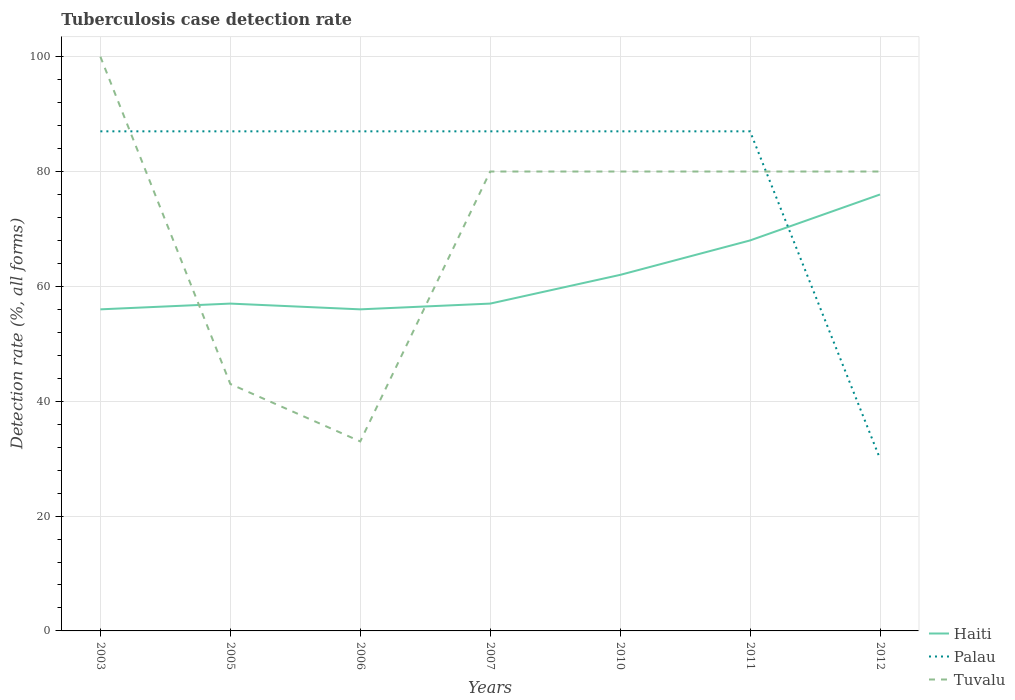How many different coloured lines are there?
Give a very brief answer. 3. Is the number of lines equal to the number of legend labels?
Make the answer very short. Yes. What is the difference between the highest and the second highest tuberculosis case detection rate in in Palau?
Ensure brevity in your answer.  57. What is the difference between two consecutive major ticks on the Y-axis?
Keep it short and to the point. 20. Are the values on the major ticks of Y-axis written in scientific E-notation?
Keep it short and to the point. No. Does the graph contain any zero values?
Provide a succinct answer. No. How are the legend labels stacked?
Keep it short and to the point. Vertical. What is the title of the graph?
Give a very brief answer. Tuberculosis case detection rate. Does "Ireland" appear as one of the legend labels in the graph?
Offer a terse response. No. What is the label or title of the X-axis?
Your answer should be compact. Years. What is the label or title of the Y-axis?
Give a very brief answer. Detection rate (%, all forms). What is the Detection rate (%, all forms) in Haiti in 2003?
Offer a very short reply. 56. What is the Detection rate (%, all forms) of Palau in 2003?
Offer a terse response. 87. What is the Detection rate (%, all forms) in Haiti in 2005?
Give a very brief answer. 57. What is the Detection rate (%, all forms) of Palau in 2005?
Keep it short and to the point. 87. What is the Detection rate (%, all forms) in Haiti in 2006?
Provide a succinct answer. 56. What is the Detection rate (%, all forms) in Palau in 2006?
Give a very brief answer. 87. What is the Detection rate (%, all forms) of Tuvalu in 2006?
Your answer should be very brief. 33. What is the Detection rate (%, all forms) of Haiti in 2007?
Your answer should be very brief. 57. What is the Detection rate (%, all forms) of Palau in 2007?
Keep it short and to the point. 87. What is the Detection rate (%, all forms) of Palau in 2010?
Offer a terse response. 87. What is the Detection rate (%, all forms) of Tuvalu in 2010?
Offer a very short reply. 80. What is the Detection rate (%, all forms) in Haiti in 2011?
Give a very brief answer. 68. What is the Detection rate (%, all forms) of Tuvalu in 2011?
Your answer should be compact. 80. What is the Detection rate (%, all forms) of Haiti in 2012?
Give a very brief answer. 76. What is the Detection rate (%, all forms) in Palau in 2012?
Offer a terse response. 30. Across all years, what is the maximum Detection rate (%, all forms) in Haiti?
Offer a very short reply. 76. Across all years, what is the maximum Detection rate (%, all forms) of Palau?
Provide a succinct answer. 87. Across all years, what is the maximum Detection rate (%, all forms) of Tuvalu?
Provide a short and direct response. 100. Across all years, what is the minimum Detection rate (%, all forms) of Palau?
Ensure brevity in your answer.  30. What is the total Detection rate (%, all forms) of Haiti in the graph?
Your answer should be compact. 432. What is the total Detection rate (%, all forms) of Palau in the graph?
Your answer should be compact. 552. What is the total Detection rate (%, all forms) in Tuvalu in the graph?
Your answer should be very brief. 496. What is the difference between the Detection rate (%, all forms) in Palau in 2003 and that in 2006?
Offer a very short reply. 0. What is the difference between the Detection rate (%, all forms) of Tuvalu in 2003 and that in 2006?
Make the answer very short. 67. What is the difference between the Detection rate (%, all forms) in Tuvalu in 2003 and that in 2007?
Your answer should be compact. 20. What is the difference between the Detection rate (%, all forms) in Palau in 2003 and that in 2010?
Give a very brief answer. 0. What is the difference between the Detection rate (%, all forms) of Haiti in 2003 and that in 2011?
Provide a short and direct response. -12. What is the difference between the Detection rate (%, all forms) of Haiti in 2003 and that in 2012?
Give a very brief answer. -20. What is the difference between the Detection rate (%, all forms) in Tuvalu in 2003 and that in 2012?
Provide a succinct answer. 20. What is the difference between the Detection rate (%, all forms) in Palau in 2005 and that in 2006?
Your answer should be very brief. 0. What is the difference between the Detection rate (%, all forms) of Palau in 2005 and that in 2007?
Your answer should be very brief. 0. What is the difference between the Detection rate (%, all forms) in Tuvalu in 2005 and that in 2007?
Make the answer very short. -37. What is the difference between the Detection rate (%, all forms) of Palau in 2005 and that in 2010?
Your answer should be very brief. 0. What is the difference between the Detection rate (%, all forms) in Tuvalu in 2005 and that in 2010?
Provide a succinct answer. -37. What is the difference between the Detection rate (%, all forms) of Palau in 2005 and that in 2011?
Give a very brief answer. 0. What is the difference between the Detection rate (%, all forms) of Tuvalu in 2005 and that in 2011?
Give a very brief answer. -37. What is the difference between the Detection rate (%, all forms) of Palau in 2005 and that in 2012?
Offer a terse response. 57. What is the difference between the Detection rate (%, all forms) of Tuvalu in 2005 and that in 2012?
Offer a terse response. -37. What is the difference between the Detection rate (%, all forms) of Tuvalu in 2006 and that in 2007?
Keep it short and to the point. -47. What is the difference between the Detection rate (%, all forms) in Haiti in 2006 and that in 2010?
Provide a succinct answer. -6. What is the difference between the Detection rate (%, all forms) in Tuvalu in 2006 and that in 2010?
Your response must be concise. -47. What is the difference between the Detection rate (%, all forms) of Haiti in 2006 and that in 2011?
Offer a terse response. -12. What is the difference between the Detection rate (%, all forms) in Palau in 2006 and that in 2011?
Your answer should be very brief. 0. What is the difference between the Detection rate (%, all forms) in Tuvalu in 2006 and that in 2011?
Make the answer very short. -47. What is the difference between the Detection rate (%, all forms) in Haiti in 2006 and that in 2012?
Provide a succinct answer. -20. What is the difference between the Detection rate (%, all forms) of Palau in 2006 and that in 2012?
Offer a very short reply. 57. What is the difference between the Detection rate (%, all forms) in Tuvalu in 2006 and that in 2012?
Make the answer very short. -47. What is the difference between the Detection rate (%, all forms) in Haiti in 2007 and that in 2010?
Your response must be concise. -5. What is the difference between the Detection rate (%, all forms) of Tuvalu in 2007 and that in 2011?
Provide a short and direct response. 0. What is the difference between the Detection rate (%, all forms) in Palau in 2007 and that in 2012?
Your answer should be compact. 57. What is the difference between the Detection rate (%, all forms) of Palau in 2010 and that in 2012?
Your response must be concise. 57. What is the difference between the Detection rate (%, all forms) of Tuvalu in 2010 and that in 2012?
Your answer should be very brief. 0. What is the difference between the Detection rate (%, all forms) of Haiti in 2011 and that in 2012?
Make the answer very short. -8. What is the difference between the Detection rate (%, all forms) of Tuvalu in 2011 and that in 2012?
Keep it short and to the point. 0. What is the difference between the Detection rate (%, all forms) in Haiti in 2003 and the Detection rate (%, all forms) in Palau in 2005?
Your answer should be compact. -31. What is the difference between the Detection rate (%, all forms) of Haiti in 2003 and the Detection rate (%, all forms) of Tuvalu in 2005?
Provide a short and direct response. 13. What is the difference between the Detection rate (%, all forms) of Haiti in 2003 and the Detection rate (%, all forms) of Palau in 2006?
Provide a succinct answer. -31. What is the difference between the Detection rate (%, all forms) of Haiti in 2003 and the Detection rate (%, all forms) of Tuvalu in 2006?
Your answer should be compact. 23. What is the difference between the Detection rate (%, all forms) of Palau in 2003 and the Detection rate (%, all forms) of Tuvalu in 2006?
Ensure brevity in your answer.  54. What is the difference between the Detection rate (%, all forms) in Haiti in 2003 and the Detection rate (%, all forms) in Palau in 2007?
Provide a short and direct response. -31. What is the difference between the Detection rate (%, all forms) in Haiti in 2003 and the Detection rate (%, all forms) in Tuvalu in 2007?
Your answer should be compact. -24. What is the difference between the Detection rate (%, all forms) of Haiti in 2003 and the Detection rate (%, all forms) of Palau in 2010?
Offer a terse response. -31. What is the difference between the Detection rate (%, all forms) of Haiti in 2003 and the Detection rate (%, all forms) of Tuvalu in 2010?
Offer a terse response. -24. What is the difference between the Detection rate (%, all forms) in Palau in 2003 and the Detection rate (%, all forms) in Tuvalu in 2010?
Ensure brevity in your answer.  7. What is the difference between the Detection rate (%, all forms) of Haiti in 2003 and the Detection rate (%, all forms) of Palau in 2011?
Keep it short and to the point. -31. What is the difference between the Detection rate (%, all forms) of Haiti in 2003 and the Detection rate (%, all forms) of Tuvalu in 2012?
Make the answer very short. -24. What is the difference between the Detection rate (%, all forms) of Palau in 2003 and the Detection rate (%, all forms) of Tuvalu in 2012?
Offer a terse response. 7. What is the difference between the Detection rate (%, all forms) in Haiti in 2005 and the Detection rate (%, all forms) in Palau in 2006?
Your answer should be very brief. -30. What is the difference between the Detection rate (%, all forms) of Haiti in 2005 and the Detection rate (%, all forms) of Tuvalu in 2006?
Offer a very short reply. 24. What is the difference between the Detection rate (%, all forms) in Haiti in 2005 and the Detection rate (%, all forms) in Tuvalu in 2007?
Give a very brief answer. -23. What is the difference between the Detection rate (%, all forms) of Haiti in 2005 and the Detection rate (%, all forms) of Palau in 2010?
Provide a short and direct response. -30. What is the difference between the Detection rate (%, all forms) in Palau in 2005 and the Detection rate (%, all forms) in Tuvalu in 2010?
Keep it short and to the point. 7. What is the difference between the Detection rate (%, all forms) in Haiti in 2005 and the Detection rate (%, all forms) in Tuvalu in 2011?
Make the answer very short. -23. What is the difference between the Detection rate (%, all forms) in Haiti in 2006 and the Detection rate (%, all forms) in Palau in 2007?
Keep it short and to the point. -31. What is the difference between the Detection rate (%, all forms) in Haiti in 2006 and the Detection rate (%, all forms) in Tuvalu in 2007?
Give a very brief answer. -24. What is the difference between the Detection rate (%, all forms) of Palau in 2006 and the Detection rate (%, all forms) of Tuvalu in 2007?
Provide a succinct answer. 7. What is the difference between the Detection rate (%, all forms) in Haiti in 2006 and the Detection rate (%, all forms) in Palau in 2010?
Offer a terse response. -31. What is the difference between the Detection rate (%, all forms) in Haiti in 2006 and the Detection rate (%, all forms) in Tuvalu in 2010?
Make the answer very short. -24. What is the difference between the Detection rate (%, all forms) of Haiti in 2006 and the Detection rate (%, all forms) of Palau in 2011?
Make the answer very short. -31. What is the difference between the Detection rate (%, all forms) in Haiti in 2006 and the Detection rate (%, all forms) in Tuvalu in 2011?
Provide a succinct answer. -24. What is the difference between the Detection rate (%, all forms) in Haiti in 2006 and the Detection rate (%, all forms) in Palau in 2012?
Your answer should be very brief. 26. What is the difference between the Detection rate (%, all forms) in Haiti in 2006 and the Detection rate (%, all forms) in Tuvalu in 2012?
Your answer should be compact. -24. What is the difference between the Detection rate (%, all forms) in Palau in 2006 and the Detection rate (%, all forms) in Tuvalu in 2012?
Give a very brief answer. 7. What is the difference between the Detection rate (%, all forms) of Haiti in 2007 and the Detection rate (%, all forms) of Palau in 2010?
Offer a very short reply. -30. What is the difference between the Detection rate (%, all forms) in Haiti in 2007 and the Detection rate (%, all forms) in Tuvalu in 2010?
Make the answer very short. -23. What is the difference between the Detection rate (%, all forms) of Haiti in 2007 and the Detection rate (%, all forms) of Palau in 2011?
Give a very brief answer. -30. What is the difference between the Detection rate (%, all forms) of Haiti in 2007 and the Detection rate (%, all forms) of Tuvalu in 2011?
Keep it short and to the point. -23. What is the difference between the Detection rate (%, all forms) in Haiti in 2007 and the Detection rate (%, all forms) in Tuvalu in 2012?
Your answer should be very brief. -23. What is the difference between the Detection rate (%, all forms) in Haiti in 2010 and the Detection rate (%, all forms) in Palau in 2011?
Offer a terse response. -25. What is the difference between the Detection rate (%, all forms) in Haiti in 2010 and the Detection rate (%, all forms) in Tuvalu in 2011?
Your answer should be compact. -18. What is the difference between the Detection rate (%, all forms) of Palau in 2010 and the Detection rate (%, all forms) of Tuvalu in 2011?
Give a very brief answer. 7. What is the difference between the Detection rate (%, all forms) of Haiti in 2010 and the Detection rate (%, all forms) of Palau in 2012?
Your answer should be compact. 32. What is the difference between the Detection rate (%, all forms) of Palau in 2010 and the Detection rate (%, all forms) of Tuvalu in 2012?
Offer a very short reply. 7. What is the difference between the Detection rate (%, all forms) in Haiti in 2011 and the Detection rate (%, all forms) in Palau in 2012?
Provide a succinct answer. 38. What is the difference between the Detection rate (%, all forms) of Haiti in 2011 and the Detection rate (%, all forms) of Tuvalu in 2012?
Your answer should be very brief. -12. What is the difference between the Detection rate (%, all forms) of Palau in 2011 and the Detection rate (%, all forms) of Tuvalu in 2012?
Your answer should be very brief. 7. What is the average Detection rate (%, all forms) of Haiti per year?
Your answer should be very brief. 61.71. What is the average Detection rate (%, all forms) in Palau per year?
Your answer should be compact. 78.86. What is the average Detection rate (%, all forms) of Tuvalu per year?
Give a very brief answer. 70.86. In the year 2003, what is the difference between the Detection rate (%, all forms) of Haiti and Detection rate (%, all forms) of Palau?
Your answer should be very brief. -31. In the year 2003, what is the difference between the Detection rate (%, all forms) of Haiti and Detection rate (%, all forms) of Tuvalu?
Keep it short and to the point. -44. In the year 2005, what is the difference between the Detection rate (%, all forms) of Haiti and Detection rate (%, all forms) of Tuvalu?
Your answer should be very brief. 14. In the year 2005, what is the difference between the Detection rate (%, all forms) of Palau and Detection rate (%, all forms) of Tuvalu?
Give a very brief answer. 44. In the year 2006, what is the difference between the Detection rate (%, all forms) in Haiti and Detection rate (%, all forms) in Palau?
Make the answer very short. -31. In the year 2006, what is the difference between the Detection rate (%, all forms) in Palau and Detection rate (%, all forms) in Tuvalu?
Provide a short and direct response. 54. In the year 2007, what is the difference between the Detection rate (%, all forms) of Palau and Detection rate (%, all forms) of Tuvalu?
Your answer should be very brief. 7. In the year 2010, what is the difference between the Detection rate (%, all forms) of Haiti and Detection rate (%, all forms) of Palau?
Provide a short and direct response. -25. In the year 2011, what is the difference between the Detection rate (%, all forms) of Haiti and Detection rate (%, all forms) of Tuvalu?
Offer a very short reply. -12. In the year 2012, what is the difference between the Detection rate (%, all forms) in Haiti and Detection rate (%, all forms) in Palau?
Keep it short and to the point. 46. In the year 2012, what is the difference between the Detection rate (%, all forms) in Haiti and Detection rate (%, all forms) in Tuvalu?
Your answer should be very brief. -4. What is the ratio of the Detection rate (%, all forms) of Haiti in 2003 to that in 2005?
Offer a terse response. 0.98. What is the ratio of the Detection rate (%, all forms) in Palau in 2003 to that in 2005?
Your response must be concise. 1. What is the ratio of the Detection rate (%, all forms) of Tuvalu in 2003 to that in 2005?
Offer a very short reply. 2.33. What is the ratio of the Detection rate (%, all forms) of Tuvalu in 2003 to that in 2006?
Provide a succinct answer. 3.03. What is the ratio of the Detection rate (%, all forms) in Haiti in 2003 to that in 2007?
Provide a succinct answer. 0.98. What is the ratio of the Detection rate (%, all forms) of Haiti in 2003 to that in 2010?
Your answer should be compact. 0.9. What is the ratio of the Detection rate (%, all forms) of Palau in 2003 to that in 2010?
Provide a succinct answer. 1. What is the ratio of the Detection rate (%, all forms) in Haiti in 2003 to that in 2011?
Offer a very short reply. 0.82. What is the ratio of the Detection rate (%, all forms) in Palau in 2003 to that in 2011?
Your response must be concise. 1. What is the ratio of the Detection rate (%, all forms) of Tuvalu in 2003 to that in 2011?
Ensure brevity in your answer.  1.25. What is the ratio of the Detection rate (%, all forms) of Haiti in 2003 to that in 2012?
Offer a very short reply. 0.74. What is the ratio of the Detection rate (%, all forms) of Palau in 2003 to that in 2012?
Provide a succinct answer. 2.9. What is the ratio of the Detection rate (%, all forms) in Tuvalu in 2003 to that in 2012?
Your answer should be very brief. 1.25. What is the ratio of the Detection rate (%, all forms) of Haiti in 2005 to that in 2006?
Provide a short and direct response. 1.02. What is the ratio of the Detection rate (%, all forms) of Palau in 2005 to that in 2006?
Provide a short and direct response. 1. What is the ratio of the Detection rate (%, all forms) of Tuvalu in 2005 to that in 2006?
Provide a succinct answer. 1.3. What is the ratio of the Detection rate (%, all forms) in Palau in 2005 to that in 2007?
Your response must be concise. 1. What is the ratio of the Detection rate (%, all forms) in Tuvalu in 2005 to that in 2007?
Give a very brief answer. 0.54. What is the ratio of the Detection rate (%, all forms) in Haiti in 2005 to that in 2010?
Offer a terse response. 0.92. What is the ratio of the Detection rate (%, all forms) of Palau in 2005 to that in 2010?
Offer a very short reply. 1. What is the ratio of the Detection rate (%, all forms) of Tuvalu in 2005 to that in 2010?
Make the answer very short. 0.54. What is the ratio of the Detection rate (%, all forms) in Haiti in 2005 to that in 2011?
Make the answer very short. 0.84. What is the ratio of the Detection rate (%, all forms) in Palau in 2005 to that in 2011?
Provide a short and direct response. 1. What is the ratio of the Detection rate (%, all forms) of Tuvalu in 2005 to that in 2011?
Make the answer very short. 0.54. What is the ratio of the Detection rate (%, all forms) of Tuvalu in 2005 to that in 2012?
Ensure brevity in your answer.  0.54. What is the ratio of the Detection rate (%, all forms) in Haiti in 2006 to that in 2007?
Your answer should be compact. 0.98. What is the ratio of the Detection rate (%, all forms) in Palau in 2006 to that in 2007?
Keep it short and to the point. 1. What is the ratio of the Detection rate (%, all forms) in Tuvalu in 2006 to that in 2007?
Keep it short and to the point. 0.41. What is the ratio of the Detection rate (%, all forms) of Haiti in 2006 to that in 2010?
Provide a short and direct response. 0.9. What is the ratio of the Detection rate (%, all forms) in Palau in 2006 to that in 2010?
Keep it short and to the point. 1. What is the ratio of the Detection rate (%, all forms) of Tuvalu in 2006 to that in 2010?
Offer a very short reply. 0.41. What is the ratio of the Detection rate (%, all forms) in Haiti in 2006 to that in 2011?
Provide a succinct answer. 0.82. What is the ratio of the Detection rate (%, all forms) in Palau in 2006 to that in 2011?
Ensure brevity in your answer.  1. What is the ratio of the Detection rate (%, all forms) of Tuvalu in 2006 to that in 2011?
Your response must be concise. 0.41. What is the ratio of the Detection rate (%, all forms) in Haiti in 2006 to that in 2012?
Offer a very short reply. 0.74. What is the ratio of the Detection rate (%, all forms) of Tuvalu in 2006 to that in 2012?
Give a very brief answer. 0.41. What is the ratio of the Detection rate (%, all forms) of Haiti in 2007 to that in 2010?
Ensure brevity in your answer.  0.92. What is the ratio of the Detection rate (%, all forms) of Palau in 2007 to that in 2010?
Make the answer very short. 1. What is the ratio of the Detection rate (%, all forms) of Haiti in 2007 to that in 2011?
Provide a short and direct response. 0.84. What is the ratio of the Detection rate (%, all forms) in Palau in 2007 to that in 2011?
Your answer should be compact. 1. What is the ratio of the Detection rate (%, all forms) of Palau in 2007 to that in 2012?
Provide a short and direct response. 2.9. What is the ratio of the Detection rate (%, all forms) in Tuvalu in 2007 to that in 2012?
Your answer should be very brief. 1. What is the ratio of the Detection rate (%, all forms) in Haiti in 2010 to that in 2011?
Your answer should be compact. 0.91. What is the ratio of the Detection rate (%, all forms) in Palau in 2010 to that in 2011?
Provide a short and direct response. 1. What is the ratio of the Detection rate (%, all forms) of Tuvalu in 2010 to that in 2011?
Offer a terse response. 1. What is the ratio of the Detection rate (%, all forms) of Haiti in 2010 to that in 2012?
Offer a very short reply. 0.82. What is the ratio of the Detection rate (%, all forms) of Palau in 2010 to that in 2012?
Keep it short and to the point. 2.9. What is the ratio of the Detection rate (%, all forms) of Haiti in 2011 to that in 2012?
Your answer should be very brief. 0.89. What is the ratio of the Detection rate (%, all forms) of Palau in 2011 to that in 2012?
Keep it short and to the point. 2.9. What is the difference between the highest and the second highest Detection rate (%, all forms) in Haiti?
Your answer should be compact. 8. What is the difference between the highest and the lowest Detection rate (%, all forms) in Haiti?
Offer a terse response. 20. What is the difference between the highest and the lowest Detection rate (%, all forms) of Palau?
Provide a short and direct response. 57. What is the difference between the highest and the lowest Detection rate (%, all forms) in Tuvalu?
Your answer should be very brief. 67. 